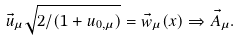<formula> <loc_0><loc_0><loc_500><loc_500>\vec { u } _ { \mu } \sqrt { 2 / ( 1 + u _ { 0 , \mu } ) } = \vec { w } _ { \mu } ( x ) \Rightarrow \vec { A } _ { \mu } .</formula> 